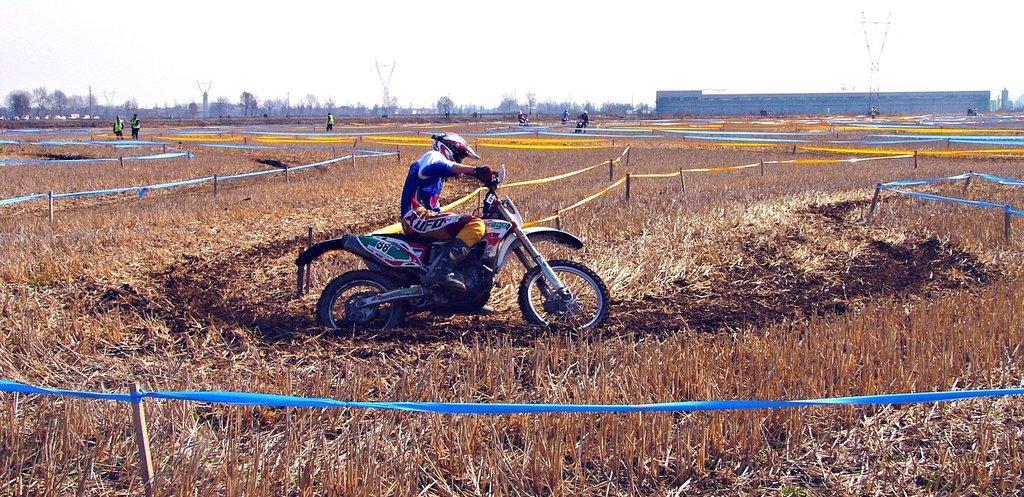Could you give a brief overview of what you see in this image? In this picture I can see group of people riding the motorbikes on the dried grass, there is a racing track, there are group of people standing, there are trees, and in the background there is sky. 